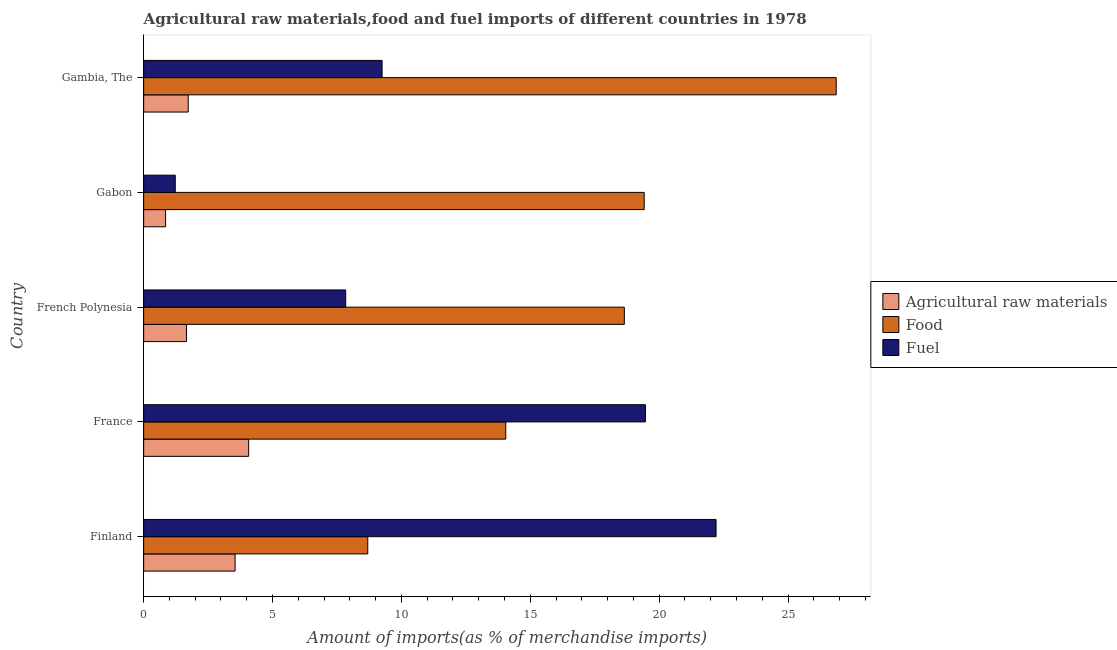Are the number of bars per tick equal to the number of legend labels?
Give a very brief answer. Yes. How many bars are there on the 5th tick from the bottom?
Provide a short and direct response. 3. What is the label of the 4th group of bars from the top?
Your answer should be very brief. France. In how many cases, is the number of bars for a given country not equal to the number of legend labels?
Keep it short and to the point. 0. What is the percentage of food imports in Gabon?
Keep it short and to the point. 19.42. Across all countries, what is the maximum percentage of food imports?
Make the answer very short. 26.87. Across all countries, what is the minimum percentage of food imports?
Keep it short and to the point. 8.69. In which country was the percentage of raw materials imports minimum?
Your answer should be compact. Gabon. What is the total percentage of fuel imports in the graph?
Keep it short and to the point. 59.99. What is the difference between the percentage of food imports in Finland and that in Gabon?
Your answer should be very brief. -10.72. What is the difference between the percentage of food imports in French Polynesia and the percentage of raw materials imports in Gabon?
Offer a terse response. 17.8. What is the average percentage of raw materials imports per country?
Provide a succinct answer. 2.37. What is the difference between the percentage of food imports and percentage of raw materials imports in Gambia, The?
Your answer should be compact. 25.14. What is the ratio of the percentage of raw materials imports in Finland to that in French Polynesia?
Make the answer very short. 2.13. Is the difference between the percentage of fuel imports in Finland and Gabon greater than the difference between the percentage of raw materials imports in Finland and Gabon?
Provide a short and direct response. Yes. What is the difference between the highest and the second highest percentage of raw materials imports?
Provide a succinct answer. 0.53. What is the difference between the highest and the lowest percentage of food imports?
Ensure brevity in your answer.  18.17. Is the sum of the percentage of raw materials imports in France and Gambia, The greater than the maximum percentage of fuel imports across all countries?
Offer a very short reply. No. What does the 3rd bar from the top in French Polynesia represents?
Your response must be concise. Agricultural raw materials. What does the 3rd bar from the bottom in France represents?
Offer a very short reply. Fuel. Is it the case that in every country, the sum of the percentage of raw materials imports and percentage of food imports is greater than the percentage of fuel imports?
Your answer should be very brief. No. Are all the bars in the graph horizontal?
Give a very brief answer. Yes. What is the difference between two consecutive major ticks on the X-axis?
Your answer should be compact. 5. Does the graph contain any zero values?
Make the answer very short. No. Where does the legend appear in the graph?
Your response must be concise. Center right. What is the title of the graph?
Make the answer very short. Agricultural raw materials,food and fuel imports of different countries in 1978. What is the label or title of the X-axis?
Your response must be concise. Amount of imports(as % of merchandise imports). What is the label or title of the Y-axis?
Offer a terse response. Country. What is the Amount of imports(as % of merchandise imports) in Agricultural raw materials in Finland?
Make the answer very short. 3.55. What is the Amount of imports(as % of merchandise imports) in Food in Finland?
Keep it short and to the point. 8.69. What is the Amount of imports(as % of merchandise imports) of Fuel in Finland?
Make the answer very short. 22.21. What is the Amount of imports(as % of merchandise imports) in Agricultural raw materials in France?
Offer a very short reply. 4.07. What is the Amount of imports(as % of merchandise imports) of Food in France?
Ensure brevity in your answer.  14.05. What is the Amount of imports(as % of merchandise imports) in Fuel in France?
Give a very brief answer. 19.47. What is the Amount of imports(as % of merchandise imports) of Agricultural raw materials in French Polynesia?
Keep it short and to the point. 1.66. What is the Amount of imports(as % of merchandise imports) in Food in French Polynesia?
Keep it short and to the point. 18.65. What is the Amount of imports(as % of merchandise imports) in Fuel in French Polynesia?
Make the answer very short. 7.84. What is the Amount of imports(as % of merchandise imports) in Agricultural raw materials in Gabon?
Provide a succinct answer. 0.85. What is the Amount of imports(as % of merchandise imports) of Food in Gabon?
Provide a short and direct response. 19.42. What is the Amount of imports(as % of merchandise imports) of Fuel in Gabon?
Offer a very short reply. 1.23. What is the Amount of imports(as % of merchandise imports) of Agricultural raw materials in Gambia, The?
Offer a very short reply. 1.73. What is the Amount of imports(as % of merchandise imports) in Food in Gambia, The?
Ensure brevity in your answer.  26.87. What is the Amount of imports(as % of merchandise imports) in Fuel in Gambia, The?
Your response must be concise. 9.25. Across all countries, what is the maximum Amount of imports(as % of merchandise imports) of Agricultural raw materials?
Provide a short and direct response. 4.07. Across all countries, what is the maximum Amount of imports(as % of merchandise imports) of Food?
Your answer should be compact. 26.87. Across all countries, what is the maximum Amount of imports(as % of merchandise imports) in Fuel?
Keep it short and to the point. 22.21. Across all countries, what is the minimum Amount of imports(as % of merchandise imports) of Agricultural raw materials?
Provide a short and direct response. 0.85. Across all countries, what is the minimum Amount of imports(as % of merchandise imports) of Food?
Your answer should be compact. 8.69. Across all countries, what is the minimum Amount of imports(as % of merchandise imports) in Fuel?
Make the answer very short. 1.23. What is the total Amount of imports(as % of merchandise imports) of Agricultural raw materials in the graph?
Offer a very short reply. 11.86. What is the total Amount of imports(as % of merchandise imports) in Food in the graph?
Provide a short and direct response. 87.68. What is the total Amount of imports(as % of merchandise imports) of Fuel in the graph?
Offer a very short reply. 59.99. What is the difference between the Amount of imports(as % of merchandise imports) in Agricultural raw materials in Finland and that in France?
Ensure brevity in your answer.  -0.53. What is the difference between the Amount of imports(as % of merchandise imports) of Food in Finland and that in France?
Your response must be concise. -5.35. What is the difference between the Amount of imports(as % of merchandise imports) of Fuel in Finland and that in France?
Offer a very short reply. 2.74. What is the difference between the Amount of imports(as % of merchandise imports) in Agricultural raw materials in Finland and that in French Polynesia?
Offer a very short reply. 1.89. What is the difference between the Amount of imports(as % of merchandise imports) of Food in Finland and that in French Polynesia?
Keep it short and to the point. -9.95. What is the difference between the Amount of imports(as % of merchandise imports) in Fuel in Finland and that in French Polynesia?
Offer a terse response. 14.37. What is the difference between the Amount of imports(as % of merchandise imports) of Agricultural raw materials in Finland and that in Gabon?
Offer a terse response. 2.7. What is the difference between the Amount of imports(as % of merchandise imports) in Food in Finland and that in Gabon?
Provide a succinct answer. -10.72. What is the difference between the Amount of imports(as % of merchandise imports) of Fuel in Finland and that in Gabon?
Make the answer very short. 20.98. What is the difference between the Amount of imports(as % of merchandise imports) of Agricultural raw materials in Finland and that in Gambia, The?
Give a very brief answer. 1.82. What is the difference between the Amount of imports(as % of merchandise imports) in Food in Finland and that in Gambia, The?
Offer a terse response. -18.17. What is the difference between the Amount of imports(as % of merchandise imports) in Fuel in Finland and that in Gambia, The?
Provide a succinct answer. 12.96. What is the difference between the Amount of imports(as % of merchandise imports) of Agricultural raw materials in France and that in French Polynesia?
Your answer should be very brief. 2.41. What is the difference between the Amount of imports(as % of merchandise imports) of Food in France and that in French Polynesia?
Provide a succinct answer. -4.6. What is the difference between the Amount of imports(as % of merchandise imports) in Fuel in France and that in French Polynesia?
Your answer should be very brief. 11.63. What is the difference between the Amount of imports(as % of merchandise imports) in Agricultural raw materials in France and that in Gabon?
Ensure brevity in your answer.  3.22. What is the difference between the Amount of imports(as % of merchandise imports) in Food in France and that in Gabon?
Your answer should be very brief. -5.37. What is the difference between the Amount of imports(as % of merchandise imports) in Fuel in France and that in Gabon?
Keep it short and to the point. 18.24. What is the difference between the Amount of imports(as % of merchandise imports) of Agricultural raw materials in France and that in Gambia, The?
Keep it short and to the point. 2.34. What is the difference between the Amount of imports(as % of merchandise imports) in Food in France and that in Gambia, The?
Offer a very short reply. -12.82. What is the difference between the Amount of imports(as % of merchandise imports) of Fuel in France and that in Gambia, The?
Offer a terse response. 10.22. What is the difference between the Amount of imports(as % of merchandise imports) in Agricultural raw materials in French Polynesia and that in Gabon?
Ensure brevity in your answer.  0.81. What is the difference between the Amount of imports(as % of merchandise imports) of Food in French Polynesia and that in Gabon?
Ensure brevity in your answer.  -0.77. What is the difference between the Amount of imports(as % of merchandise imports) in Fuel in French Polynesia and that in Gabon?
Ensure brevity in your answer.  6.61. What is the difference between the Amount of imports(as % of merchandise imports) of Agricultural raw materials in French Polynesia and that in Gambia, The?
Your response must be concise. -0.07. What is the difference between the Amount of imports(as % of merchandise imports) in Food in French Polynesia and that in Gambia, The?
Ensure brevity in your answer.  -8.22. What is the difference between the Amount of imports(as % of merchandise imports) in Fuel in French Polynesia and that in Gambia, The?
Keep it short and to the point. -1.41. What is the difference between the Amount of imports(as % of merchandise imports) of Agricultural raw materials in Gabon and that in Gambia, The?
Ensure brevity in your answer.  -0.88. What is the difference between the Amount of imports(as % of merchandise imports) in Food in Gabon and that in Gambia, The?
Give a very brief answer. -7.45. What is the difference between the Amount of imports(as % of merchandise imports) of Fuel in Gabon and that in Gambia, The?
Keep it short and to the point. -8.02. What is the difference between the Amount of imports(as % of merchandise imports) of Agricultural raw materials in Finland and the Amount of imports(as % of merchandise imports) of Food in France?
Provide a short and direct response. -10.5. What is the difference between the Amount of imports(as % of merchandise imports) of Agricultural raw materials in Finland and the Amount of imports(as % of merchandise imports) of Fuel in France?
Your answer should be compact. -15.92. What is the difference between the Amount of imports(as % of merchandise imports) in Food in Finland and the Amount of imports(as % of merchandise imports) in Fuel in France?
Offer a terse response. -10.77. What is the difference between the Amount of imports(as % of merchandise imports) of Agricultural raw materials in Finland and the Amount of imports(as % of merchandise imports) of Food in French Polynesia?
Provide a succinct answer. -15.1. What is the difference between the Amount of imports(as % of merchandise imports) of Agricultural raw materials in Finland and the Amount of imports(as % of merchandise imports) of Fuel in French Polynesia?
Your answer should be compact. -4.29. What is the difference between the Amount of imports(as % of merchandise imports) in Food in Finland and the Amount of imports(as % of merchandise imports) in Fuel in French Polynesia?
Make the answer very short. 0.86. What is the difference between the Amount of imports(as % of merchandise imports) of Agricultural raw materials in Finland and the Amount of imports(as % of merchandise imports) of Food in Gabon?
Ensure brevity in your answer.  -15.87. What is the difference between the Amount of imports(as % of merchandise imports) in Agricultural raw materials in Finland and the Amount of imports(as % of merchandise imports) in Fuel in Gabon?
Make the answer very short. 2.32. What is the difference between the Amount of imports(as % of merchandise imports) in Food in Finland and the Amount of imports(as % of merchandise imports) in Fuel in Gabon?
Offer a terse response. 7.47. What is the difference between the Amount of imports(as % of merchandise imports) in Agricultural raw materials in Finland and the Amount of imports(as % of merchandise imports) in Food in Gambia, The?
Your answer should be compact. -23.32. What is the difference between the Amount of imports(as % of merchandise imports) of Agricultural raw materials in Finland and the Amount of imports(as % of merchandise imports) of Fuel in Gambia, The?
Keep it short and to the point. -5.7. What is the difference between the Amount of imports(as % of merchandise imports) of Food in Finland and the Amount of imports(as % of merchandise imports) of Fuel in Gambia, The?
Provide a succinct answer. -0.56. What is the difference between the Amount of imports(as % of merchandise imports) of Agricultural raw materials in France and the Amount of imports(as % of merchandise imports) of Food in French Polynesia?
Offer a very short reply. -14.57. What is the difference between the Amount of imports(as % of merchandise imports) of Agricultural raw materials in France and the Amount of imports(as % of merchandise imports) of Fuel in French Polynesia?
Keep it short and to the point. -3.76. What is the difference between the Amount of imports(as % of merchandise imports) in Food in France and the Amount of imports(as % of merchandise imports) in Fuel in French Polynesia?
Your answer should be very brief. 6.21. What is the difference between the Amount of imports(as % of merchandise imports) in Agricultural raw materials in France and the Amount of imports(as % of merchandise imports) in Food in Gabon?
Your response must be concise. -15.35. What is the difference between the Amount of imports(as % of merchandise imports) of Agricultural raw materials in France and the Amount of imports(as % of merchandise imports) of Fuel in Gabon?
Keep it short and to the point. 2.85. What is the difference between the Amount of imports(as % of merchandise imports) in Food in France and the Amount of imports(as % of merchandise imports) in Fuel in Gabon?
Ensure brevity in your answer.  12.82. What is the difference between the Amount of imports(as % of merchandise imports) in Agricultural raw materials in France and the Amount of imports(as % of merchandise imports) in Food in Gambia, The?
Your response must be concise. -22.79. What is the difference between the Amount of imports(as % of merchandise imports) in Agricultural raw materials in France and the Amount of imports(as % of merchandise imports) in Fuel in Gambia, The?
Offer a very short reply. -5.18. What is the difference between the Amount of imports(as % of merchandise imports) of Food in France and the Amount of imports(as % of merchandise imports) of Fuel in Gambia, The?
Keep it short and to the point. 4.8. What is the difference between the Amount of imports(as % of merchandise imports) of Agricultural raw materials in French Polynesia and the Amount of imports(as % of merchandise imports) of Food in Gabon?
Your answer should be compact. -17.76. What is the difference between the Amount of imports(as % of merchandise imports) in Agricultural raw materials in French Polynesia and the Amount of imports(as % of merchandise imports) in Fuel in Gabon?
Provide a succinct answer. 0.44. What is the difference between the Amount of imports(as % of merchandise imports) of Food in French Polynesia and the Amount of imports(as % of merchandise imports) of Fuel in Gabon?
Give a very brief answer. 17.42. What is the difference between the Amount of imports(as % of merchandise imports) of Agricultural raw materials in French Polynesia and the Amount of imports(as % of merchandise imports) of Food in Gambia, The?
Provide a succinct answer. -25.21. What is the difference between the Amount of imports(as % of merchandise imports) in Agricultural raw materials in French Polynesia and the Amount of imports(as % of merchandise imports) in Fuel in Gambia, The?
Offer a terse response. -7.59. What is the difference between the Amount of imports(as % of merchandise imports) of Food in French Polynesia and the Amount of imports(as % of merchandise imports) of Fuel in Gambia, The?
Offer a very short reply. 9.4. What is the difference between the Amount of imports(as % of merchandise imports) in Agricultural raw materials in Gabon and the Amount of imports(as % of merchandise imports) in Food in Gambia, The?
Your response must be concise. -26.02. What is the difference between the Amount of imports(as % of merchandise imports) of Agricultural raw materials in Gabon and the Amount of imports(as % of merchandise imports) of Fuel in Gambia, The?
Provide a short and direct response. -8.4. What is the difference between the Amount of imports(as % of merchandise imports) in Food in Gabon and the Amount of imports(as % of merchandise imports) in Fuel in Gambia, The?
Your answer should be compact. 10.17. What is the average Amount of imports(as % of merchandise imports) of Agricultural raw materials per country?
Provide a short and direct response. 2.37. What is the average Amount of imports(as % of merchandise imports) in Food per country?
Your answer should be very brief. 17.54. What is the average Amount of imports(as % of merchandise imports) of Fuel per country?
Give a very brief answer. 12. What is the difference between the Amount of imports(as % of merchandise imports) of Agricultural raw materials and Amount of imports(as % of merchandise imports) of Food in Finland?
Make the answer very short. -5.15. What is the difference between the Amount of imports(as % of merchandise imports) of Agricultural raw materials and Amount of imports(as % of merchandise imports) of Fuel in Finland?
Your answer should be compact. -18.66. What is the difference between the Amount of imports(as % of merchandise imports) of Food and Amount of imports(as % of merchandise imports) of Fuel in Finland?
Make the answer very short. -13.51. What is the difference between the Amount of imports(as % of merchandise imports) in Agricultural raw materials and Amount of imports(as % of merchandise imports) in Food in France?
Your answer should be compact. -9.97. What is the difference between the Amount of imports(as % of merchandise imports) of Agricultural raw materials and Amount of imports(as % of merchandise imports) of Fuel in France?
Offer a very short reply. -15.39. What is the difference between the Amount of imports(as % of merchandise imports) of Food and Amount of imports(as % of merchandise imports) of Fuel in France?
Make the answer very short. -5.42. What is the difference between the Amount of imports(as % of merchandise imports) of Agricultural raw materials and Amount of imports(as % of merchandise imports) of Food in French Polynesia?
Make the answer very short. -16.99. What is the difference between the Amount of imports(as % of merchandise imports) of Agricultural raw materials and Amount of imports(as % of merchandise imports) of Fuel in French Polynesia?
Provide a short and direct response. -6.18. What is the difference between the Amount of imports(as % of merchandise imports) in Food and Amount of imports(as % of merchandise imports) in Fuel in French Polynesia?
Offer a very short reply. 10.81. What is the difference between the Amount of imports(as % of merchandise imports) in Agricultural raw materials and Amount of imports(as % of merchandise imports) in Food in Gabon?
Make the answer very short. -18.57. What is the difference between the Amount of imports(as % of merchandise imports) in Agricultural raw materials and Amount of imports(as % of merchandise imports) in Fuel in Gabon?
Provide a short and direct response. -0.38. What is the difference between the Amount of imports(as % of merchandise imports) of Food and Amount of imports(as % of merchandise imports) of Fuel in Gabon?
Your response must be concise. 18.19. What is the difference between the Amount of imports(as % of merchandise imports) of Agricultural raw materials and Amount of imports(as % of merchandise imports) of Food in Gambia, The?
Your answer should be compact. -25.14. What is the difference between the Amount of imports(as % of merchandise imports) in Agricultural raw materials and Amount of imports(as % of merchandise imports) in Fuel in Gambia, The?
Ensure brevity in your answer.  -7.52. What is the difference between the Amount of imports(as % of merchandise imports) in Food and Amount of imports(as % of merchandise imports) in Fuel in Gambia, The?
Your response must be concise. 17.62. What is the ratio of the Amount of imports(as % of merchandise imports) of Agricultural raw materials in Finland to that in France?
Provide a short and direct response. 0.87. What is the ratio of the Amount of imports(as % of merchandise imports) of Food in Finland to that in France?
Your answer should be very brief. 0.62. What is the ratio of the Amount of imports(as % of merchandise imports) in Fuel in Finland to that in France?
Provide a short and direct response. 1.14. What is the ratio of the Amount of imports(as % of merchandise imports) of Agricultural raw materials in Finland to that in French Polynesia?
Ensure brevity in your answer.  2.13. What is the ratio of the Amount of imports(as % of merchandise imports) of Food in Finland to that in French Polynesia?
Provide a succinct answer. 0.47. What is the ratio of the Amount of imports(as % of merchandise imports) of Fuel in Finland to that in French Polynesia?
Give a very brief answer. 2.83. What is the ratio of the Amount of imports(as % of merchandise imports) in Agricultural raw materials in Finland to that in Gabon?
Provide a short and direct response. 4.17. What is the ratio of the Amount of imports(as % of merchandise imports) of Food in Finland to that in Gabon?
Provide a succinct answer. 0.45. What is the ratio of the Amount of imports(as % of merchandise imports) of Fuel in Finland to that in Gabon?
Keep it short and to the point. 18.1. What is the ratio of the Amount of imports(as % of merchandise imports) in Agricultural raw materials in Finland to that in Gambia, The?
Your answer should be very brief. 2.05. What is the ratio of the Amount of imports(as % of merchandise imports) of Food in Finland to that in Gambia, The?
Provide a succinct answer. 0.32. What is the ratio of the Amount of imports(as % of merchandise imports) of Fuel in Finland to that in Gambia, The?
Ensure brevity in your answer.  2.4. What is the ratio of the Amount of imports(as % of merchandise imports) of Agricultural raw materials in France to that in French Polynesia?
Offer a terse response. 2.45. What is the ratio of the Amount of imports(as % of merchandise imports) in Food in France to that in French Polynesia?
Give a very brief answer. 0.75. What is the ratio of the Amount of imports(as % of merchandise imports) of Fuel in France to that in French Polynesia?
Your response must be concise. 2.48. What is the ratio of the Amount of imports(as % of merchandise imports) in Agricultural raw materials in France to that in Gabon?
Provide a short and direct response. 4.79. What is the ratio of the Amount of imports(as % of merchandise imports) of Food in France to that in Gabon?
Your answer should be very brief. 0.72. What is the ratio of the Amount of imports(as % of merchandise imports) in Fuel in France to that in Gabon?
Make the answer very short. 15.87. What is the ratio of the Amount of imports(as % of merchandise imports) of Agricultural raw materials in France to that in Gambia, The?
Your answer should be compact. 2.36. What is the ratio of the Amount of imports(as % of merchandise imports) in Food in France to that in Gambia, The?
Your answer should be very brief. 0.52. What is the ratio of the Amount of imports(as % of merchandise imports) of Fuel in France to that in Gambia, The?
Provide a succinct answer. 2.1. What is the ratio of the Amount of imports(as % of merchandise imports) in Agricultural raw materials in French Polynesia to that in Gabon?
Ensure brevity in your answer.  1.95. What is the ratio of the Amount of imports(as % of merchandise imports) in Food in French Polynesia to that in Gabon?
Your response must be concise. 0.96. What is the ratio of the Amount of imports(as % of merchandise imports) in Fuel in French Polynesia to that in Gabon?
Provide a succinct answer. 6.39. What is the ratio of the Amount of imports(as % of merchandise imports) of Agricultural raw materials in French Polynesia to that in Gambia, The?
Give a very brief answer. 0.96. What is the ratio of the Amount of imports(as % of merchandise imports) in Food in French Polynesia to that in Gambia, The?
Provide a short and direct response. 0.69. What is the ratio of the Amount of imports(as % of merchandise imports) in Fuel in French Polynesia to that in Gambia, The?
Make the answer very short. 0.85. What is the ratio of the Amount of imports(as % of merchandise imports) in Agricultural raw materials in Gabon to that in Gambia, The?
Your answer should be very brief. 0.49. What is the ratio of the Amount of imports(as % of merchandise imports) in Food in Gabon to that in Gambia, The?
Offer a terse response. 0.72. What is the ratio of the Amount of imports(as % of merchandise imports) in Fuel in Gabon to that in Gambia, The?
Your answer should be very brief. 0.13. What is the difference between the highest and the second highest Amount of imports(as % of merchandise imports) in Agricultural raw materials?
Your answer should be compact. 0.53. What is the difference between the highest and the second highest Amount of imports(as % of merchandise imports) of Food?
Ensure brevity in your answer.  7.45. What is the difference between the highest and the second highest Amount of imports(as % of merchandise imports) in Fuel?
Give a very brief answer. 2.74. What is the difference between the highest and the lowest Amount of imports(as % of merchandise imports) in Agricultural raw materials?
Make the answer very short. 3.22. What is the difference between the highest and the lowest Amount of imports(as % of merchandise imports) of Food?
Your response must be concise. 18.17. What is the difference between the highest and the lowest Amount of imports(as % of merchandise imports) in Fuel?
Provide a short and direct response. 20.98. 